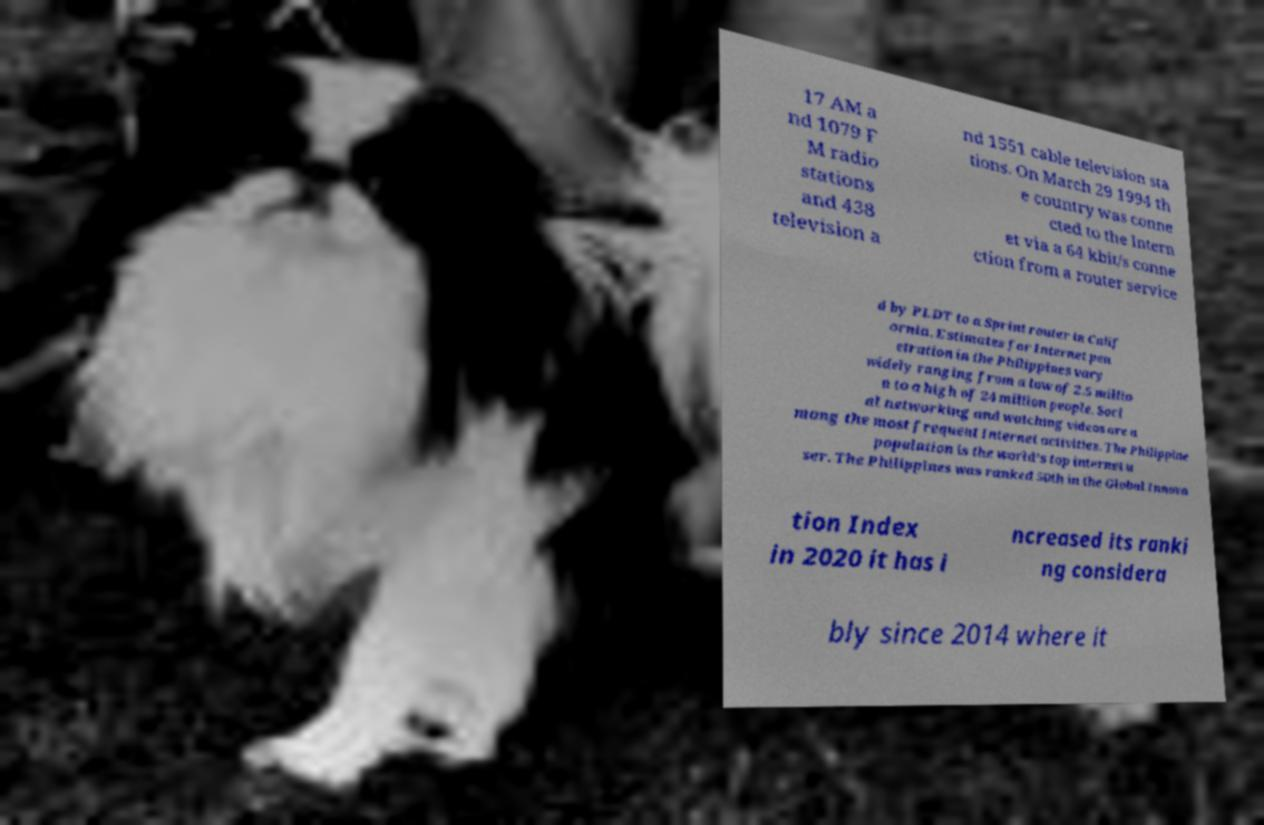I need the written content from this picture converted into text. Can you do that? 17 AM a nd 1079 F M radio stations and 438 television a nd 1551 cable television sta tions. On March 29 1994 th e country was conne cted to the Intern et via a 64 kbit/s conne ction from a router service d by PLDT to a Sprint router in Calif ornia. Estimates for Internet pen etration in the Philippines vary widely ranging from a low of 2.5 millio n to a high of 24 million people. Soci al networking and watching videos are a mong the most frequent Internet activities. The Philippine population is the world's top internet u ser. The Philippines was ranked 50th in the Global Innova tion Index in 2020 it has i ncreased its ranki ng considera bly since 2014 where it 